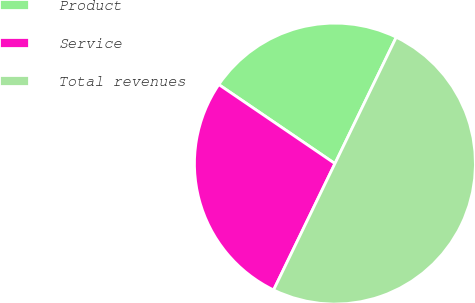Convert chart. <chart><loc_0><loc_0><loc_500><loc_500><pie_chart><fcel>Product<fcel>Service<fcel>Total revenues<nl><fcel>22.68%<fcel>27.32%<fcel>50.0%<nl></chart> 